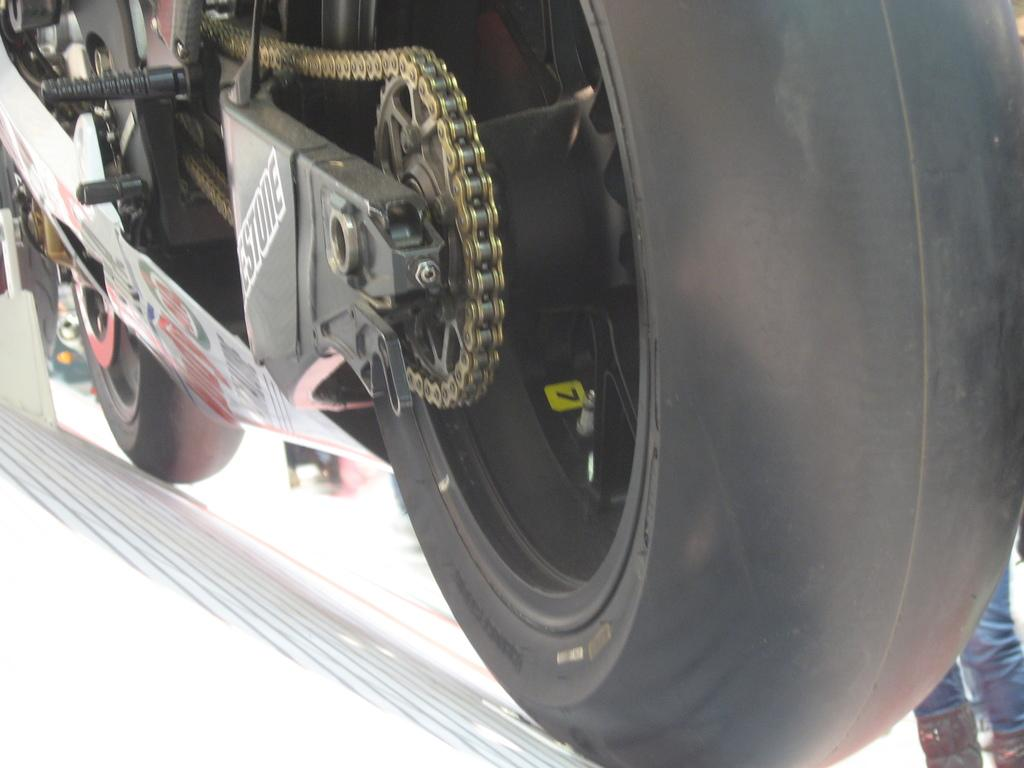What is the main object in the image? There is a bike in the image. Can you describe any other elements in the image? The legs of persons are visible in the image. What arithmetic problem is being solved by the apparatus in the image? There is no apparatus or arithmetic problem present in the image; it only features a bike and the legs of persons. 